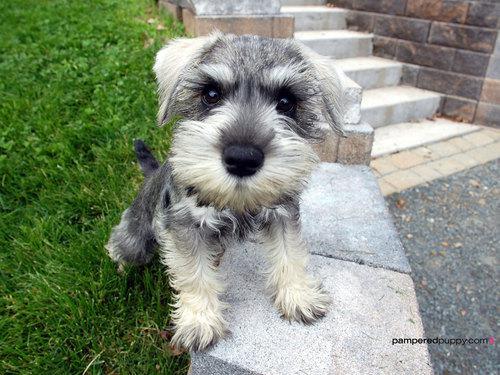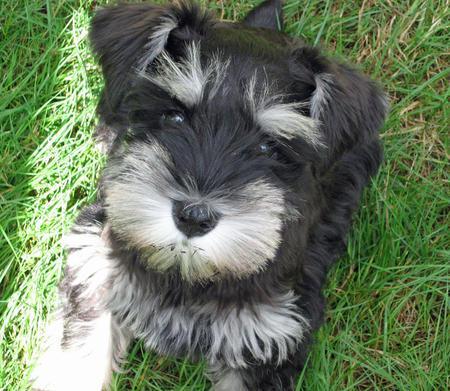The first image is the image on the left, the second image is the image on the right. Analyze the images presented: Is the assertion "At least one of the dogs is sitting on the cement." valid? Answer yes or no. Yes. 